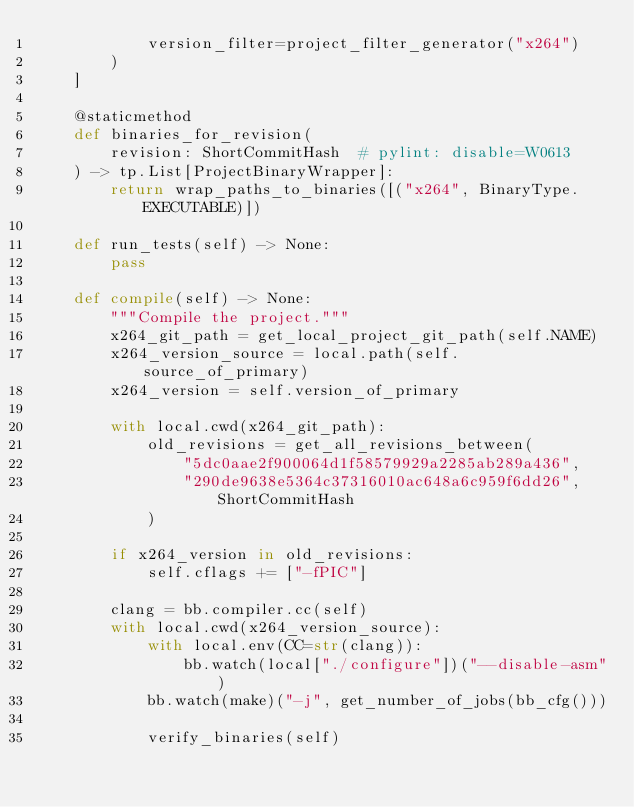Convert code to text. <code><loc_0><loc_0><loc_500><loc_500><_Python_>            version_filter=project_filter_generator("x264")
        )
    ]

    @staticmethod
    def binaries_for_revision(
        revision: ShortCommitHash  # pylint: disable=W0613
    ) -> tp.List[ProjectBinaryWrapper]:
        return wrap_paths_to_binaries([("x264", BinaryType.EXECUTABLE)])

    def run_tests(self) -> None:
        pass

    def compile(self) -> None:
        """Compile the project."""
        x264_git_path = get_local_project_git_path(self.NAME)
        x264_version_source = local.path(self.source_of_primary)
        x264_version = self.version_of_primary

        with local.cwd(x264_git_path):
            old_revisions = get_all_revisions_between(
                "5dc0aae2f900064d1f58579929a2285ab289a436",
                "290de9638e5364c37316010ac648a6c959f6dd26", ShortCommitHash
            )

        if x264_version in old_revisions:
            self.cflags += ["-fPIC"]

        clang = bb.compiler.cc(self)
        with local.cwd(x264_version_source):
            with local.env(CC=str(clang)):
                bb.watch(local["./configure"])("--disable-asm")
            bb.watch(make)("-j", get_number_of_jobs(bb_cfg()))

            verify_binaries(self)
</code> 